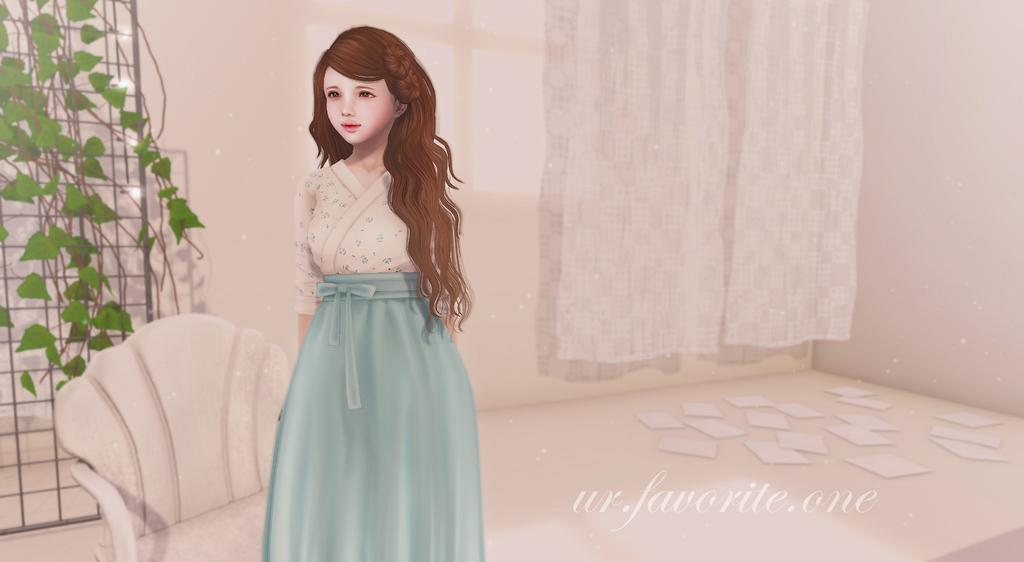What type of image is being described? The image is an animation. What piece of furniture is present in the image? There is a chair in the image. What is the girl doing in the image? The girl is standing on the floor in the image. What type of window treatment is visible in the image? There is a curtain in the image. What type of plants are present on the grills in the image? There are creepers on the grills in the image. What is scattered on the floor in the image? There are papers on the floor in the image. What position does the drawer hold in the image? There is no drawer present in the image. Can you touch the creepers in the image? The image is an animation, so it is not possible to touch the creepers or any other elements in the image. 